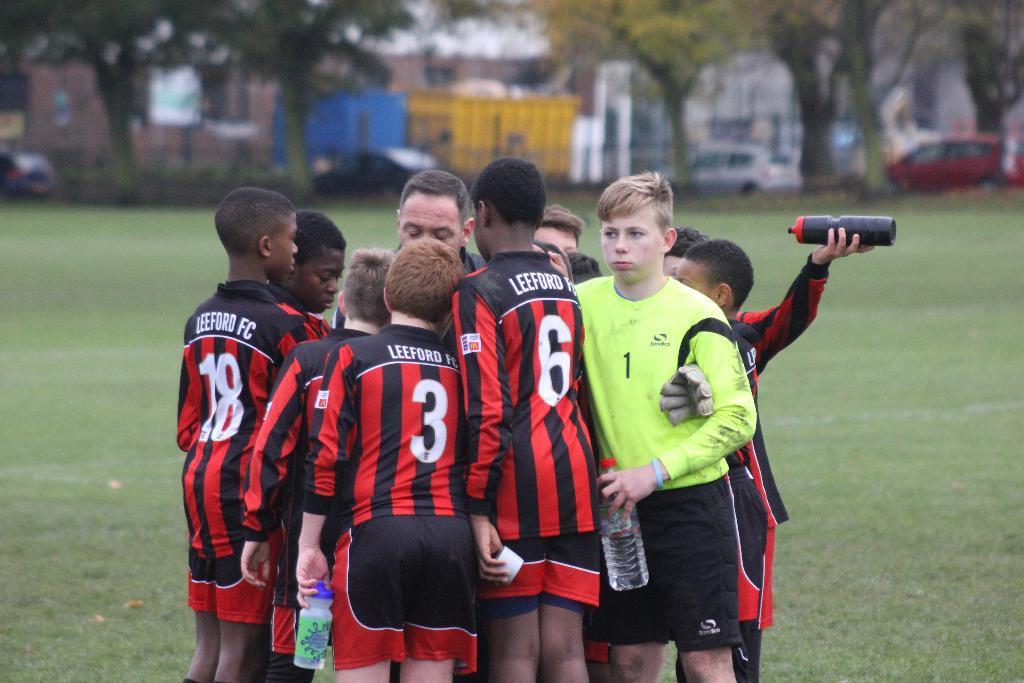How would you summarize this image in a sentence or two? In this image in the center there are some boys standing, and some of them are holding some bottles. In the background there are some buildings, trees, vehicles and a fence. At the bottom there is grass. 